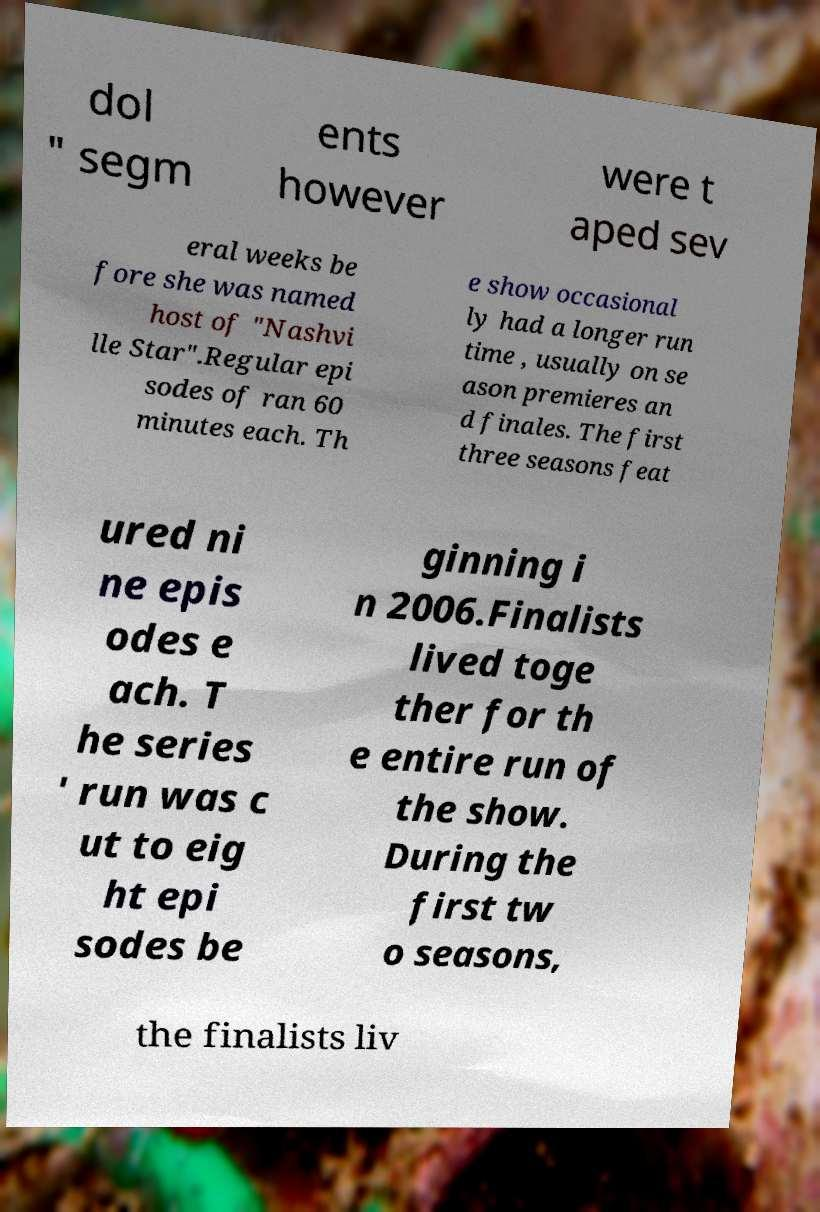There's text embedded in this image that I need extracted. Can you transcribe it verbatim? dol " segm ents however were t aped sev eral weeks be fore she was named host of "Nashvi lle Star".Regular epi sodes of ran 60 minutes each. Th e show occasional ly had a longer run time , usually on se ason premieres an d finales. The first three seasons feat ured ni ne epis odes e ach. T he series ' run was c ut to eig ht epi sodes be ginning i n 2006.Finalists lived toge ther for th e entire run of the show. During the first tw o seasons, the finalists liv 